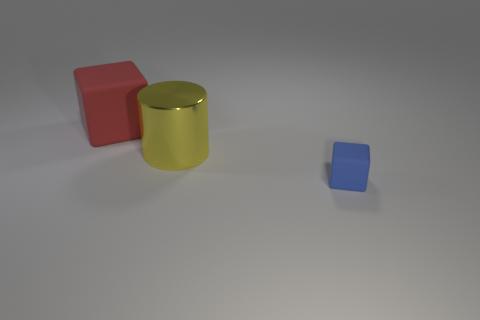Add 2 big purple cubes. How many objects exist? 5 Subtract all cubes. How many objects are left? 1 Subtract 0 blue cylinders. How many objects are left? 3 Subtract all matte cubes. Subtract all big red matte objects. How many objects are left? 0 Add 3 large cubes. How many large cubes are left? 4 Add 3 metallic cylinders. How many metallic cylinders exist? 4 